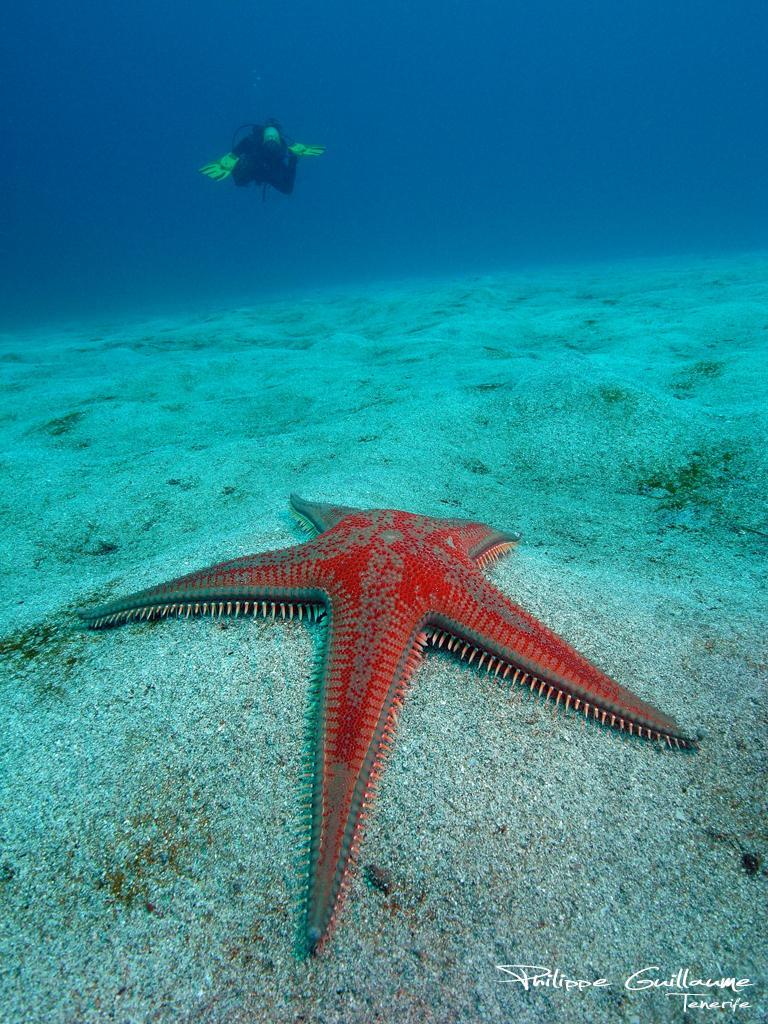Describe this image in one or two sentences. In this image I can see the underwater picture in which I can see a human swimming, the ground and a starfish which is orange in color on the ground. 